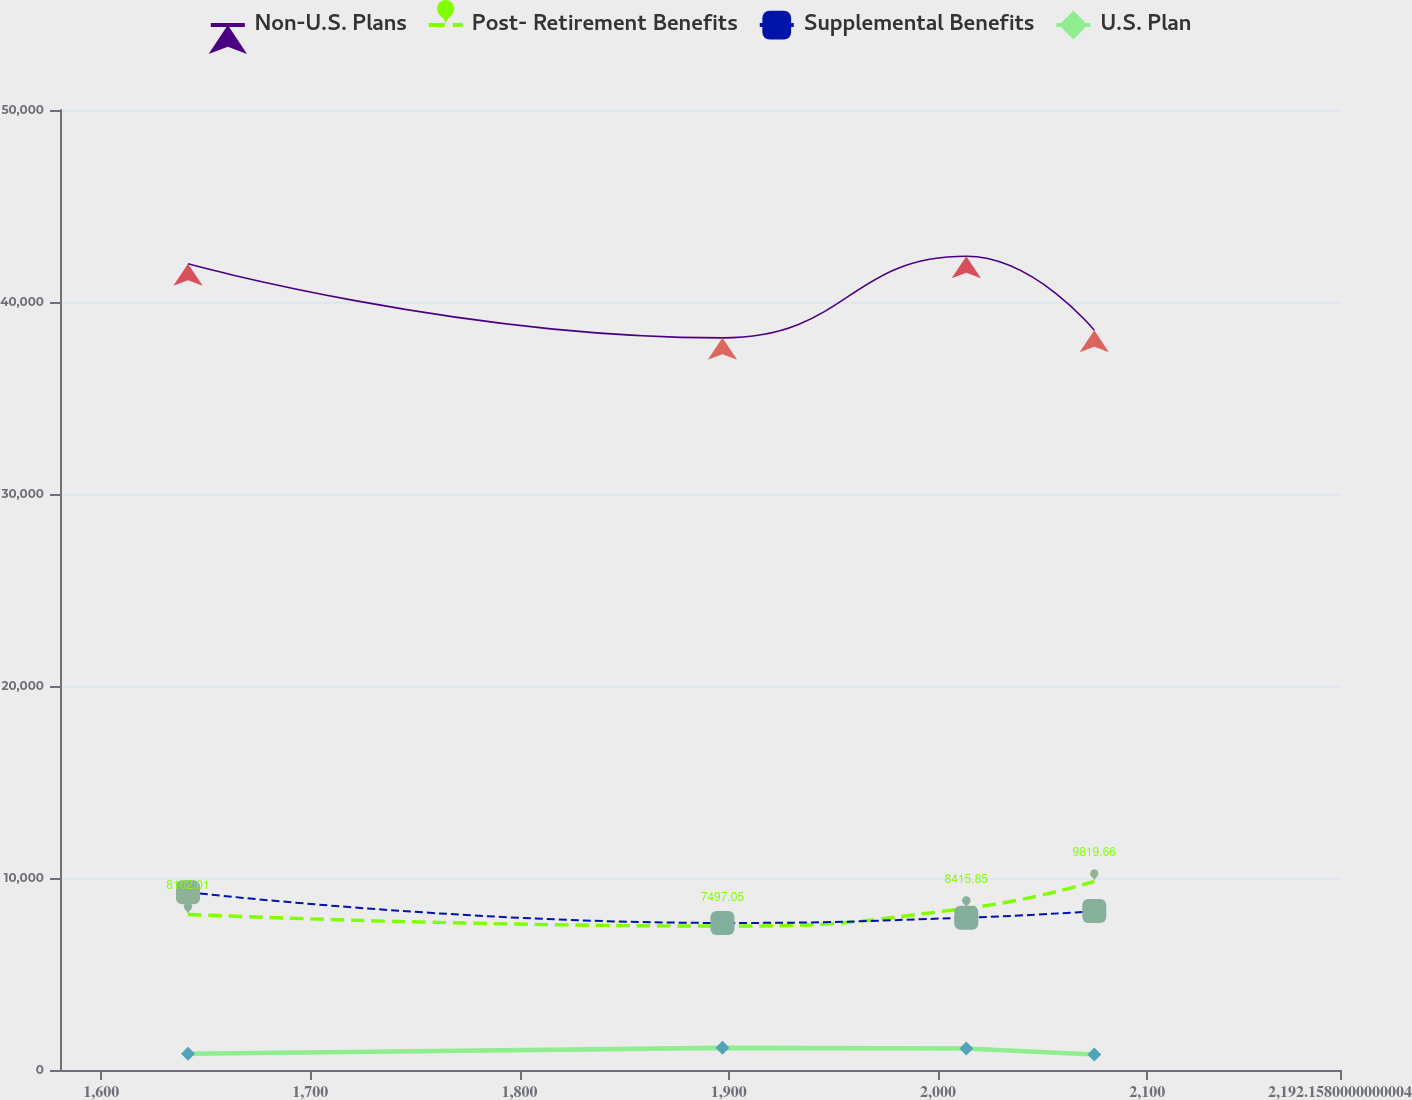<chart> <loc_0><loc_0><loc_500><loc_500><line_chart><ecel><fcel>Non-U.S. Plans<fcel>Post- Retirement Benefits<fcel>Supplemental Benefits<fcel>U.S. Plan<nl><fcel>1641.52<fcel>41987<fcel>8102.01<fcel>9263.61<fcel>843.09<nl><fcel>1896.98<fcel>38132.6<fcel>7497.05<fcel>7659.77<fcel>1154.27<nl><fcel>2013.53<fcel>42380.5<fcel>8415.85<fcel>7931.92<fcel>1122.41<nl><fcel>2074.71<fcel>38526.1<fcel>9819.66<fcel>8276.03<fcel>808.45<nl><fcel>2253.34<fcel>38919.5<fcel>7863.84<fcel>6765.45<fcel>1090.55<nl></chart> 